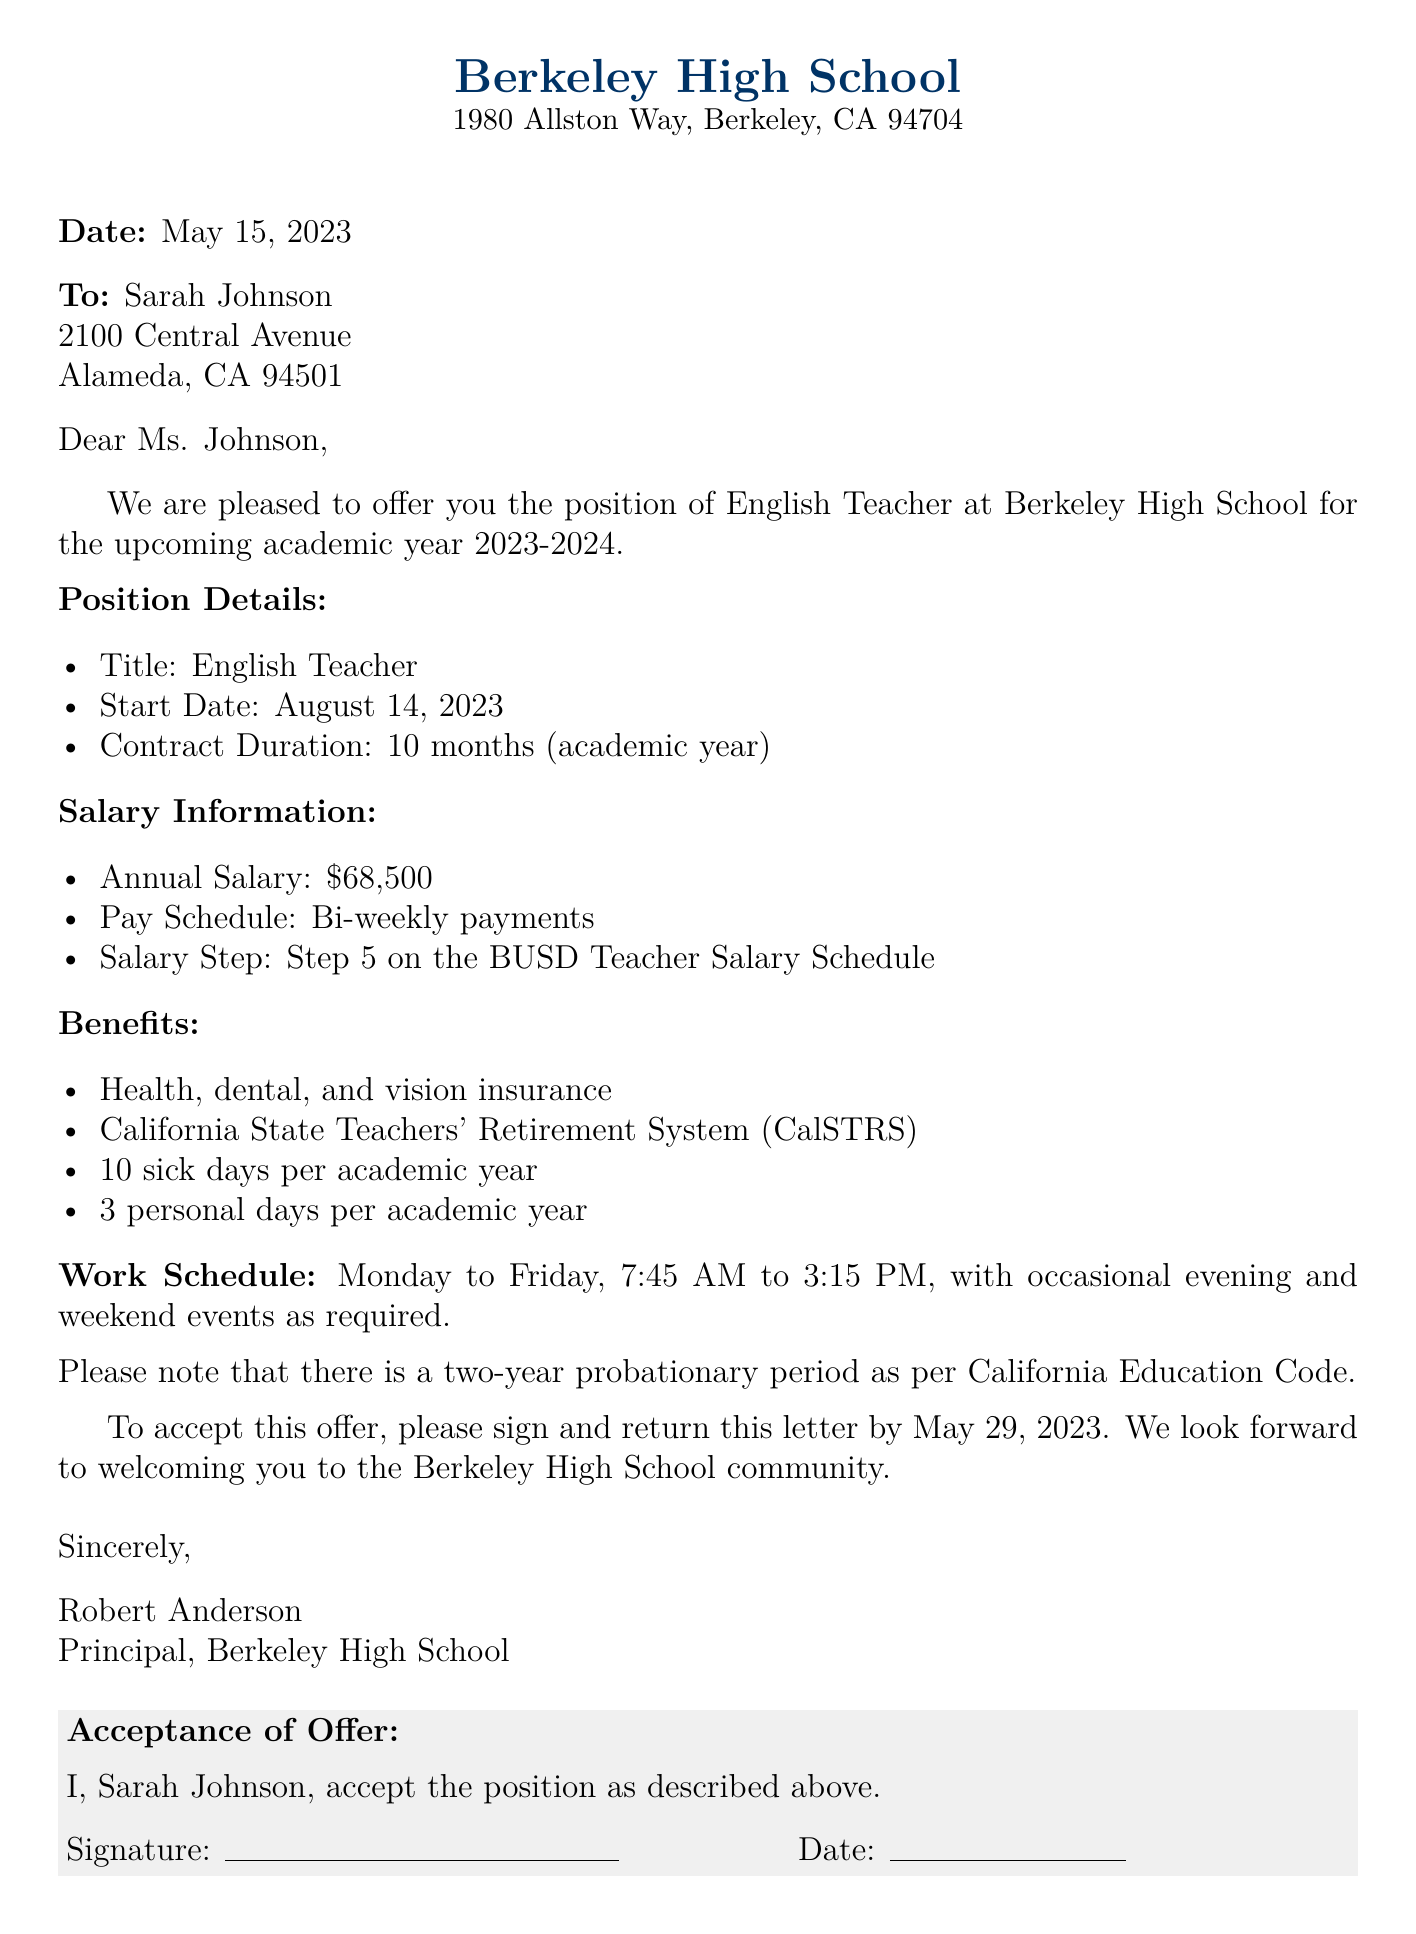What is the position title? The position title is explicitly stated in the document as "English Teacher."
Answer: English Teacher What is the annual salary? The document specifies that the annual salary for the position is $68,500.
Answer: $68,500 When does the contract start? The start date mentioned in the document is crucial for understanding the beginning of employment, which is August 14, 2023.
Answer: August 14, 2023 How many sick days are provided each year? The document indicates that the employee is entitled to 10 sick days per academic year.
Answer: 10 sick days What is the probationary period? The document mentions a two-year probationary period as per California Education Code, which is essential for understanding employment terms.
Answer: Two years What is the work schedule? The specific working hours are outlined: Monday to Friday, 7:45 AM to 3:15 PM.
Answer: Monday to Friday, 7:45 AM to 3:15 PM Who is the principal? The document directly states that Robert Anderson is the principal at Berkeley High School.
Answer: Robert Anderson What must be done to accept the job offer? The document instructs that to accept the offer, the recipient must sign and return the letter by May 29, 2023.
Answer: Sign and return by May 29, 2023 What benefits are included? The document lists health, dental, and vision insurance as part of the benefits, which is significant for understanding the total compensation.
Answer: Health, dental, and vision insurance 